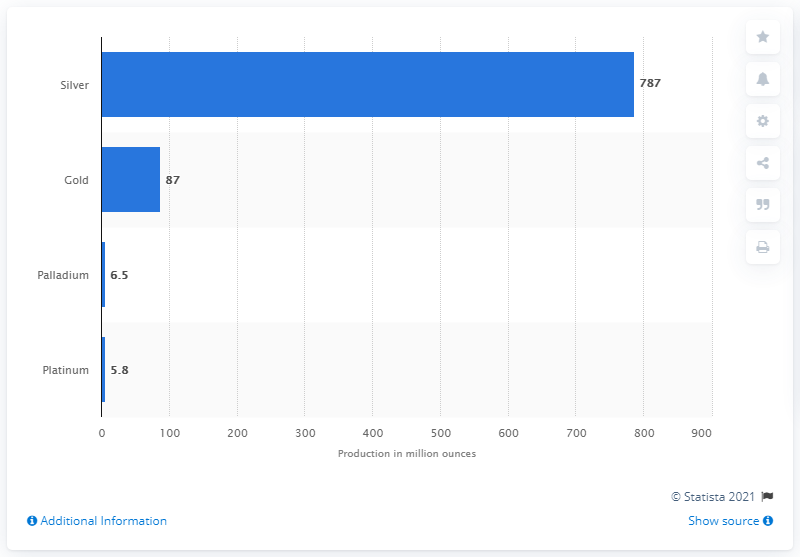Outline some significant characteristics in this image. In 2014, the world market produced approximately 6.5 ounces of palladium. 